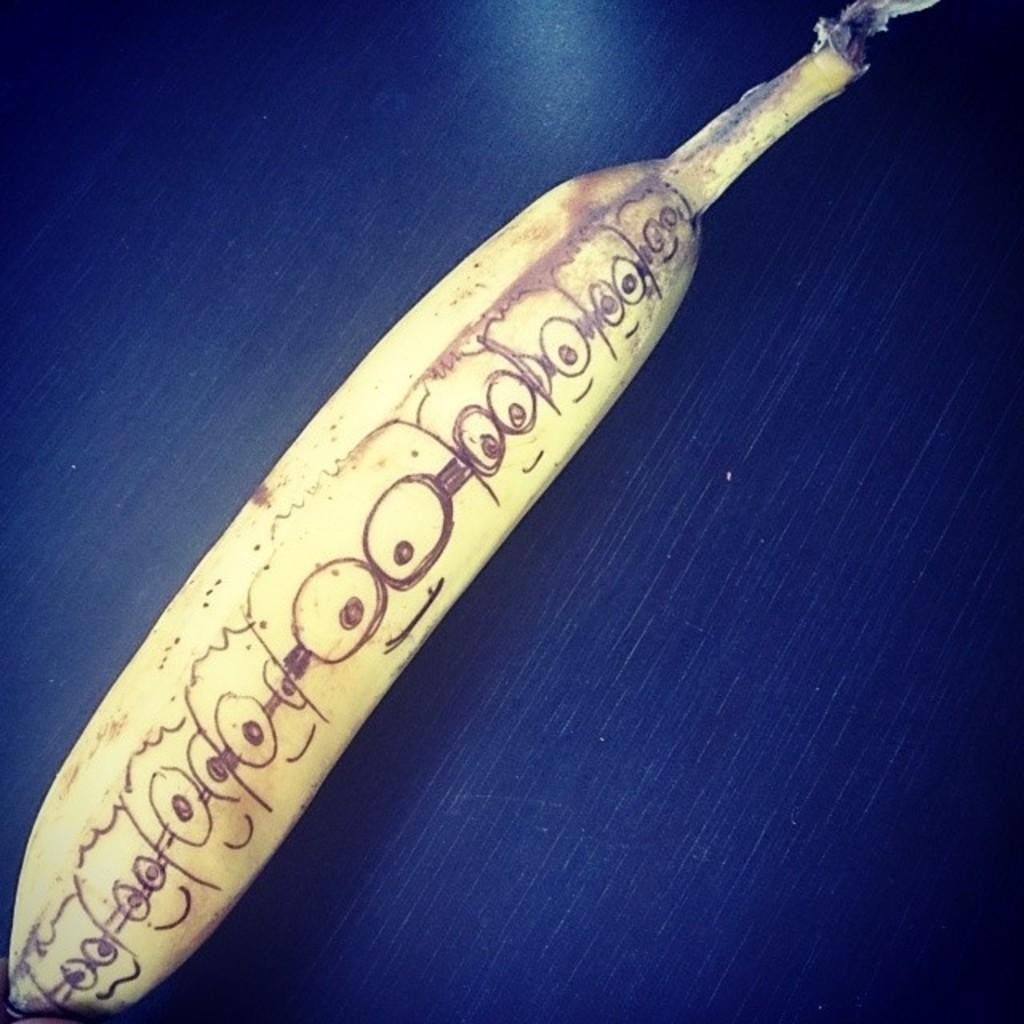What is the main subject of the image? The main subject of the image is a drawing on a banana. Where is the banana located in the image? The banana is on a platform in the image. What type of zipper is used to hold the banana together in the image? There is no zipper present in the image; it is a drawing on a banana. Can you tell me the flight number of the banana in the image? There is no flight number associated with the banana in the image; it is a drawing on a banana. 